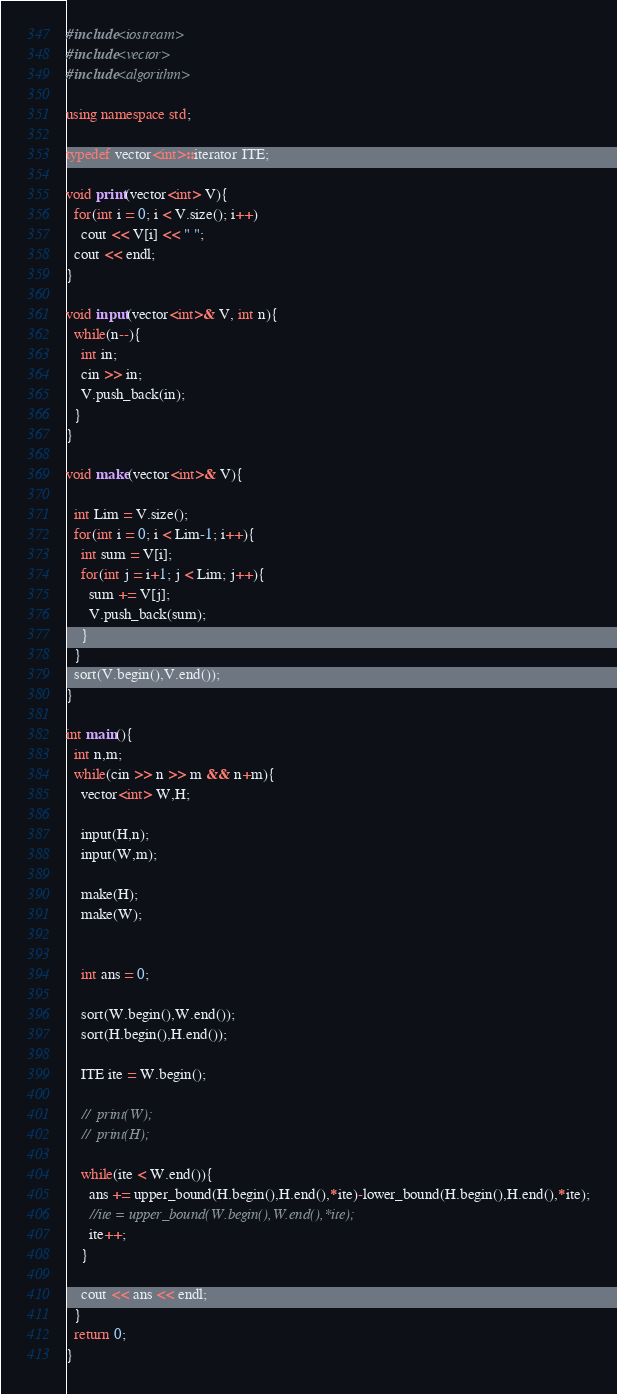<code> <loc_0><loc_0><loc_500><loc_500><_C++_>#include<iostream>
#include<vector>
#include<algorithm>

using namespace std;

typedef vector<int>::iterator ITE;

void print(vector<int> V){
  for(int i = 0; i < V.size(); i++)
    cout << V[i] << " ";
  cout << endl;
}

void input(vector<int>& V, int n){
  while(n--){
    int in;
    cin >> in;
    V.push_back(in);
  }
} 

void make(vector<int>& V){

  int Lim = V.size();
  for(int i = 0; i < Lim-1; i++){
    int sum = V[i];
    for(int j = i+1; j < Lim; j++){
      sum += V[j];
      V.push_back(sum);
    }
  }
  sort(V.begin(),V.end());
}

int main(){
  int n,m;
  while(cin >> n >> m && n+m){
    vector<int> W,H;

    input(H,n);
    input(W,m);

    make(H);
    make(W);

  
    int ans = 0;

    sort(W.begin(),W.end());
    sort(H.begin(),H.end());

    ITE ite = W.begin();

    //  print(W);
    //  print(H);

    while(ite < W.end()){
      ans += upper_bound(H.begin(),H.end(),*ite)-lower_bound(H.begin(),H.end(),*ite);
      //ite = upper_bound(W.begin(),W.end(),*ite);
      ite++;
    }

    cout << ans << endl;
  }
  return 0;
}</code> 